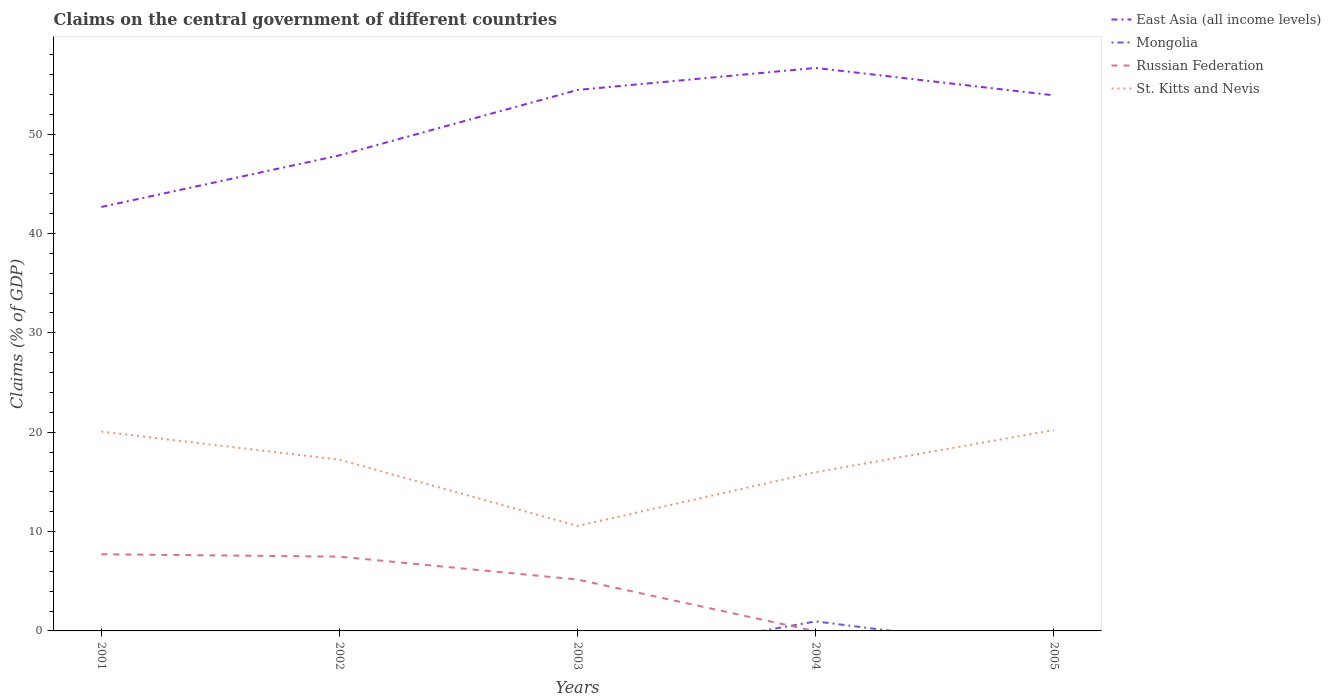Does the line corresponding to Mongolia intersect with the line corresponding to Russian Federation?
Your answer should be compact. Yes. Is the number of lines equal to the number of legend labels?
Give a very brief answer. No. What is the total percentage of GDP claimed on the central government in East Asia (all income levels) in the graph?
Your answer should be compact. -2.21. What is the difference between the highest and the second highest percentage of GDP claimed on the central government in Russian Federation?
Your answer should be compact. 7.72. What is the difference between two consecutive major ticks on the Y-axis?
Offer a very short reply. 10. Does the graph contain any zero values?
Make the answer very short. Yes. How many legend labels are there?
Your answer should be compact. 4. How are the legend labels stacked?
Ensure brevity in your answer.  Vertical. What is the title of the graph?
Offer a terse response. Claims on the central government of different countries. Does "Equatorial Guinea" appear as one of the legend labels in the graph?
Provide a succinct answer. No. What is the label or title of the X-axis?
Provide a short and direct response. Years. What is the label or title of the Y-axis?
Give a very brief answer. Claims (% of GDP). What is the Claims (% of GDP) in East Asia (all income levels) in 2001?
Provide a short and direct response. 42.67. What is the Claims (% of GDP) in Mongolia in 2001?
Keep it short and to the point. 0. What is the Claims (% of GDP) in Russian Federation in 2001?
Your answer should be very brief. 7.72. What is the Claims (% of GDP) of St. Kitts and Nevis in 2001?
Give a very brief answer. 20.07. What is the Claims (% of GDP) of East Asia (all income levels) in 2002?
Provide a succinct answer. 47.87. What is the Claims (% of GDP) of Russian Federation in 2002?
Your answer should be compact. 7.48. What is the Claims (% of GDP) in St. Kitts and Nevis in 2002?
Keep it short and to the point. 17.23. What is the Claims (% of GDP) of East Asia (all income levels) in 2003?
Give a very brief answer. 54.45. What is the Claims (% of GDP) in Mongolia in 2003?
Ensure brevity in your answer.  0. What is the Claims (% of GDP) in Russian Federation in 2003?
Offer a very short reply. 5.17. What is the Claims (% of GDP) in St. Kitts and Nevis in 2003?
Offer a very short reply. 10.57. What is the Claims (% of GDP) of East Asia (all income levels) in 2004?
Keep it short and to the point. 56.67. What is the Claims (% of GDP) of Mongolia in 2004?
Your answer should be very brief. 0.96. What is the Claims (% of GDP) in Russian Federation in 2004?
Provide a succinct answer. 0. What is the Claims (% of GDP) in St. Kitts and Nevis in 2004?
Keep it short and to the point. 15.98. What is the Claims (% of GDP) of East Asia (all income levels) in 2005?
Provide a succinct answer. 53.91. What is the Claims (% of GDP) of Russian Federation in 2005?
Keep it short and to the point. 0. What is the Claims (% of GDP) of St. Kitts and Nevis in 2005?
Offer a very short reply. 20.22. Across all years, what is the maximum Claims (% of GDP) of East Asia (all income levels)?
Make the answer very short. 56.67. Across all years, what is the maximum Claims (% of GDP) in Mongolia?
Offer a very short reply. 0.96. Across all years, what is the maximum Claims (% of GDP) of Russian Federation?
Provide a succinct answer. 7.72. Across all years, what is the maximum Claims (% of GDP) in St. Kitts and Nevis?
Keep it short and to the point. 20.22. Across all years, what is the minimum Claims (% of GDP) in East Asia (all income levels)?
Ensure brevity in your answer.  42.67. Across all years, what is the minimum Claims (% of GDP) of Russian Federation?
Ensure brevity in your answer.  0. Across all years, what is the minimum Claims (% of GDP) in St. Kitts and Nevis?
Your response must be concise. 10.57. What is the total Claims (% of GDP) of East Asia (all income levels) in the graph?
Your answer should be very brief. 255.56. What is the total Claims (% of GDP) of Russian Federation in the graph?
Provide a succinct answer. 20.37. What is the total Claims (% of GDP) in St. Kitts and Nevis in the graph?
Ensure brevity in your answer.  84.06. What is the difference between the Claims (% of GDP) in East Asia (all income levels) in 2001 and that in 2002?
Your answer should be very brief. -5.2. What is the difference between the Claims (% of GDP) of Russian Federation in 2001 and that in 2002?
Ensure brevity in your answer.  0.24. What is the difference between the Claims (% of GDP) in St. Kitts and Nevis in 2001 and that in 2002?
Give a very brief answer. 2.84. What is the difference between the Claims (% of GDP) in East Asia (all income levels) in 2001 and that in 2003?
Offer a very short reply. -11.78. What is the difference between the Claims (% of GDP) of Russian Federation in 2001 and that in 2003?
Your answer should be compact. 2.54. What is the difference between the Claims (% of GDP) in St. Kitts and Nevis in 2001 and that in 2003?
Offer a terse response. 9.5. What is the difference between the Claims (% of GDP) in East Asia (all income levels) in 2001 and that in 2004?
Keep it short and to the point. -14. What is the difference between the Claims (% of GDP) of St. Kitts and Nevis in 2001 and that in 2004?
Your response must be concise. 4.09. What is the difference between the Claims (% of GDP) in East Asia (all income levels) in 2001 and that in 2005?
Your response must be concise. -11.24. What is the difference between the Claims (% of GDP) in St. Kitts and Nevis in 2001 and that in 2005?
Ensure brevity in your answer.  -0.15. What is the difference between the Claims (% of GDP) of East Asia (all income levels) in 2002 and that in 2003?
Make the answer very short. -6.58. What is the difference between the Claims (% of GDP) in Russian Federation in 2002 and that in 2003?
Your answer should be compact. 2.3. What is the difference between the Claims (% of GDP) of St. Kitts and Nevis in 2002 and that in 2003?
Ensure brevity in your answer.  6.66. What is the difference between the Claims (% of GDP) of East Asia (all income levels) in 2002 and that in 2004?
Make the answer very short. -8.8. What is the difference between the Claims (% of GDP) of St. Kitts and Nevis in 2002 and that in 2004?
Your answer should be compact. 1.25. What is the difference between the Claims (% of GDP) of East Asia (all income levels) in 2002 and that in 2005?
Your answer should be very brief. -6.04. What is the difference between the Claims (% of GDP) in St. Kitts and Nevis in 2002 and that in 2005?
Your answer should be compact. -2.99. What is the difference between the Claims (% of GDP) of East Asia (all income levels) in 2003 and that in 2004?
Ensure brevity in your answer.  -2.21. What is the difference between the Claims (% of GDP) of St. Kitts and Nevis in 2003 and that in 2004?
Make the answer very short. -5.41. What is the difference between the Claims (% of GDP) in East Asia (all income levels) in 2003 and that in 2005?
Offer a terse response. 0.55. What is the difference between the Claims (% of GDP) of St. Kitts and Nevis in 2003 and that in 2005?
Offer a terse response. -9.65. What is the difference between the Claims (% of GDP) in East Asia (all income levels) in 2004 and that in 2005?
Provide a short and direct response. 2.76. What is the difference between the Claims (% of GDP) of St. Kitts and Nevis in 2004 and that in 2005?
Provide a succinct answer. -4.24. What is the difference between the Claims (% of GDP) in East Asia (all income levels) in 2001 and the Claims (% of GDP) in Russian Federation in 2002?
Give a very brief answer. 35.19. What is the difference between the Claims (% of GDP) in East Asia (all income levels) in 2001 and the Claims (% of GDP) in St. Kitts and Nevis in 2002?
Your answer should be very brief. 25.44. What is the difference between the Claims (% of GDP) of Russian Federation in 2001 and the Claims (% of GDP) of St. Kitts and Nevis in 2002?
Give a very brief answer. -9.51. What is the difference between the Claims (% of GDP) in East Asia (all income levels) in 2001 and the Claims (% of GDP) in Russian Federation in 2003?
Provide a succinct answer. 37.5. What is the difference between the Claims (% of GDP) in East Asia (all income levels) in 2001 and the Claims (% of GDP) in St. Kitts and Nevis in 2003?
Your response must be concise. 32.1. What is the difference between the Claims (% of GDP) in Russian Federation in 2001 and the Claims (% of GDP) in St. Kitts and Nevis in 2003?
Provide a succinct answer. -2.85. What is the difference between the Claims (% of GDP) in East Asia (all income levels) in 2001 and the Claims (% of GDP) in Mongolia in 2004?
Make the answer very short. 41.71. What is the difference between the Claims (% of GDP) of East Asia (all income levels) in 2001 and the Claims (% of GDP) of St. Kitts and Nevis in 2004?
Make the answer very short. 26.69. What is the difference between the Claims (% of GDP) in Russian Federation in 2001 and the Claims (% of GDP) in St. Kitts and Nevis in 2004?
Offer a terse response. -8.26. What is the difference between the Claims (% of GDP) in East Asia (all income levels) in 2001 and the Claims (% of GDP) in St. Kitts and Nevis in 2005?
Your response must be concise. 22.45. What is the difference between the Claims (% of GDP) in Russian Federation in 2001 and the Claims (% of GDP) in St. Kitts and Nevis in 2005?
Your answer should be compact. -12.5. What is the difference between the Claims (% of GDP) in East Asia (all income levels) in 2002 and the Claims (% of GDP) in Russian Federation in 2003?
Provide a succinct answer. 42.69. What is the difference between the Claims (% of GDP) in East Asia (all income levels) in 2002 and the Claims (% of GDP) in St. Kitts and Nevis in 2003?
Provide a succinct answer. 37.3. What is the difference between the Claims (% of GDP) in Russian Federation in 2002 and the Claims (% of GDP) in St. Kitts and Nevis in 2003?
Provide a short and direct response. -3.09. What is the difference between the Claims (% of GDP) of East Asia (all income levels) in 2002 and the Claims (% of GDP) of Mongolia in 2004?
Keep it short and to the point. 46.91. What is the difference between the Claims (% of GDP) of East Asia (all income levels) in 2002 and the Claims (% of GDP) of St. Kitts and Nevis in 2004?
Your answer should be very brief. 31.89. What is the difference between the Claims (% of GDP) of Russian Federation in 2002 and the Claims (% of GDP) of St. Kitts and Nevis in 2004?
Provide a short and direct response. -8.5. What is the difference between the Claims (% of GDP) of East Asia (all income levels) in 2002 and the Claims (% of GDP) of St. Kitts and Nevis in 2005?
Offer a very short reply. 27.65. What is the difference between the Claims (% of GDP) in Russian Federation in 2002 and the Claims (% of GDP) in St. Kitts and Nevis in 2005?
Ensure brevity in your answer.  -12.74. What is the difference between the Claims (% of GDP) in East Asia (all income levels) in 2003 and the Claims (% of GDP) in Mongolia in 2004?
Your answer should be compact. 53.49. What is the difference between the Claims (% of GDP) of East Asia (all income levels) in 2003 and the Claims (% of GDP) of St. Kitts and Nevis in 2004?
Keep it short and to the point. 38.47. What is the difference between the Claims (% of GDP) of Russian Federation in 2003 and the Claims (% of GDP) of St. Kitts and Nevis in 2004?
Provide a short and direct response. -10.8. What is the difference between the Claims (% of GDP) of East Asia (all income levels) in 2003 and the Claims (% of GDP) of St. Kitts and Nevis in 2005?
Offer a terse response. 34.23. What is the difference between the Claims (% of GDP) of Russian Federation in 2003 and the Claims (% of GDP) of St. Kitts and Nevis in 2005?
Provide a succinct answer. -15.05. What is the difference between the Claims (% of GDP) in East Asia (all income levels) in 2004 and the Claims (% of GDP) in St. Kitts and Nevis in 2005?
Give a very brief answer. 36.45. What is the difference between the Claims (% of GDP) of Mongolia in 2004 and the Claims (% of GDP) of St. Kitts and Nevis in 2005?
Your answer should be compact. -19.26. What is the average Claims (% of GDP) of East Asia (all income levels) per year?
Make the answer very short. 51.11. What is the average Claims (% of GDP) in Mongolia per year?
Make the answer very short. 0.19. What is the average Claims (% of GDP) of Russian Federation per year?
Provide a short and direct response. 4.07. What is the average Claims (% of GDP) of St. Kitts and Nevis per year?
Provide a short and direct response. 16.81. In the year 2001, what is the difference between the Claims (% of GDP) of East Asia (all income levels) and Claims (% of GDP) of Russian Federation?
Ensure brevity in your answer.  34.95. In the year 2001, what is the difference between the Claims (% of GDP) in East Asia (all income levels) and Claims (% of GDP) in St. Kitts and Nevis?
Ensure brevity in your answer.  22.6. In the year 2001, what is the difference between the Claims (% of GDP) in Russian Federation and Claims (% of GDP) in St. Kitts and Nevis?
Offer a terse response. -12.35. In the year 2002, what is the difference between the Claims (% of GDP) in East Asia (all income levels) and Claims (% of GDP) in Russian Federation?
Provide a short and direct response. 40.39. In the year 2002, what is the difference between the Claims (% of GDP) in East Asia (all income levels) and Claims (% of GDP) in St. Kitts and Nevis?
Offer a very short reply. 30.64. In the year 2002, what is the difference between the Claims (% of GDP) in Russian Federation and Claims (% of GDP) in St. Kitts and Nevis?
Ensure brevity in your answer.  -9.75. In the year 2003, what is the difference between the Claims (% of GDP) of East Asia (all income levels) and Claims (% of GDP) of Russian Federation?
Make the answer very short. 49.28. In the year 2003, what is the difference between the Claims (% of GDP) in East Asia (all income levels) and Claims (% of GDP) in St. Kitts and Nevis?
Provide a short and direct response. 43.88. In the year 2003, what is the difference between the Claims (% of GDP) of Russian Federation and Claims (% of GDP) of St. Kitts and Nevis?
Your answer should be compact. -5.39. In the year 2004, what is the difference between the Claims (% of GDP) in East Asia (all income levels) and Claims (% of GDP) in Mongolia?
Provide a short and direct response. 55.71. In the year 2004, what is the difference between the Claims (% of GDP) of East Asia (all income levels) and Claims (% of GDP) of St. Kitts and Nevis?
Offer a very short reply. 40.69. In the year 2004, what is the difference between the Claims (% of GDP) of Mongolia and Claims (% of GDP) of St. Kitts and Nevis?
Make the answer very short. -15.02. In the year 2005, what is the difference between the Claims (% of GDP) in East Asia (all income levels) and Claims (% of GDP) in St. Kitts and Nevis?
Give a very brief answer. 33.69. What is the ratio of the Claims (% of GDP) in East Asia (all income levels) in 2001 to that in 2002?
Offer a very short reply. 0.89. What is the ratio of the Claims (% of GDP) in Russian Federation in 2001 to that in 2002?
Ensure brevity in your answer.  1.03. What is the ratio of the Claims (% of GDP) in St. Kitts and Nevis in 2001 to that in 2002?
Make the answer very short. 1.16. What is the ratio of the Claims (% of GDP) of East Asia (all income levels) in 2001 to that in 2003?
Give a very brief answer. 0.78. What is the ratio of the Claims (% of GDP) of Russian Federation in 2001 to that in 2003?
Provide a succinct answer. 1.49. What is the ratio of the Claims (% of GDP) of St. Kitts and Nevis in 2001 to that in 2003?
Your answer should be compact. 1.9. What is the ratio of the Claims (% of GDP) in East Asia (all income levels) in 2001 to that in 2004?
Your answer should be very brief. 0.75. What is the ratio of the Claims (% of GDP) in St. Kitts and Nevis in 2001 to that in 2004?
Give a very brief answer. 1.26. What is the ratio of the Claims (% of GDP) of East Asia (all income levels) in 2001 to that in 2005?
Keep it short and to the point. 0.79. What is the ratio of the Claims (% of GDP) of East Asia (all income levels) in 2002 to that in 2003?
Your response must be concise. 0.88. What is the ratio of the Claims (% of GDP) in Russian Federation in 2002 to that in 2003?
Offer a very short reply. 1.45. What is the ratio of the Claims (% of GDP) of St. Kitts and Nevis in 2002 to that in 2003?
Make the answer very short. 1.63. What is the ratio of the Claims (% of GDP) of East Asia (all income levels) in 2002 to that in 2004?
Provide a short and direct response. 0.84. What is the ratio of the Claims (% of GDP) in St. Kitts and Nevis in 2002 to that in 2004?
Your response must be concise. 1.08. What is the ratio of the Claims (% of GDP) in East Asia (all income levels) in 2002 to that in 2005?
Give a very brief answer. 0.89. What is the ratio of the Claims (% of GDP) in St. Kitts and Nevis in 2002 to that in 2005?
Offer a very short reply. 0.85. What is the ratio of the Claims (% of GDP) in East Asia (all income levels) in 2003 to that in 2004?
Ensure brevity in your answer.  0.96. What is the ratio of the Claims (% of GDP) in St. Kitts and Nevis in 2003 to that in 2004?
Keep it short and to the point. 0.66. What is the ratio of the Claims (% of GDP) in East Asia (all income levels) in 2003 to that in 2005?
Offer a terse response. 1.01. What is the ratio of the Claims (% of GDP) in St. Kitts and Nevis in 2003 to that in 2005?
Your answer should be compact. 0.52. What is the ratio of the Claims (% of GDP) of East Asia (all income levels) in 2004 to that in 2005?
Make the answer very short. 1.05. What is the ratio of the Claims (% of GDP) of St. Kitts and Nevis in 2004 to that in 2005?
Provide a succinct answer. 0.79. What is the difference between the highest and the second highest Claims (% of GDP) of East Asia (all income levels)?
Ensure brevity in your answer.  2.21. What is the difference between the highest and the second highest Claims (% of GDP) of Russian Federation?
Keep it short and to the point. 0.24. What is the difference between the highest and the second highest Claims (% of GDP) of St. Kitts and Nevis?
Your answer should be very brief. 0.15. What is the difference between the highest and the lowest Claims (% of GDP) in East Asia (all income levels)?
Your answer should be very brief. 14. What is the difference between the highest and the lowest Claims (% of GDP) of Russian Federation?
Offer a very short reply. 7.72. What is the difference between the highest and the lowest Claims (% of GDP) in St. Kitts and Nevis?
Your answer should be compact. 9.65. 